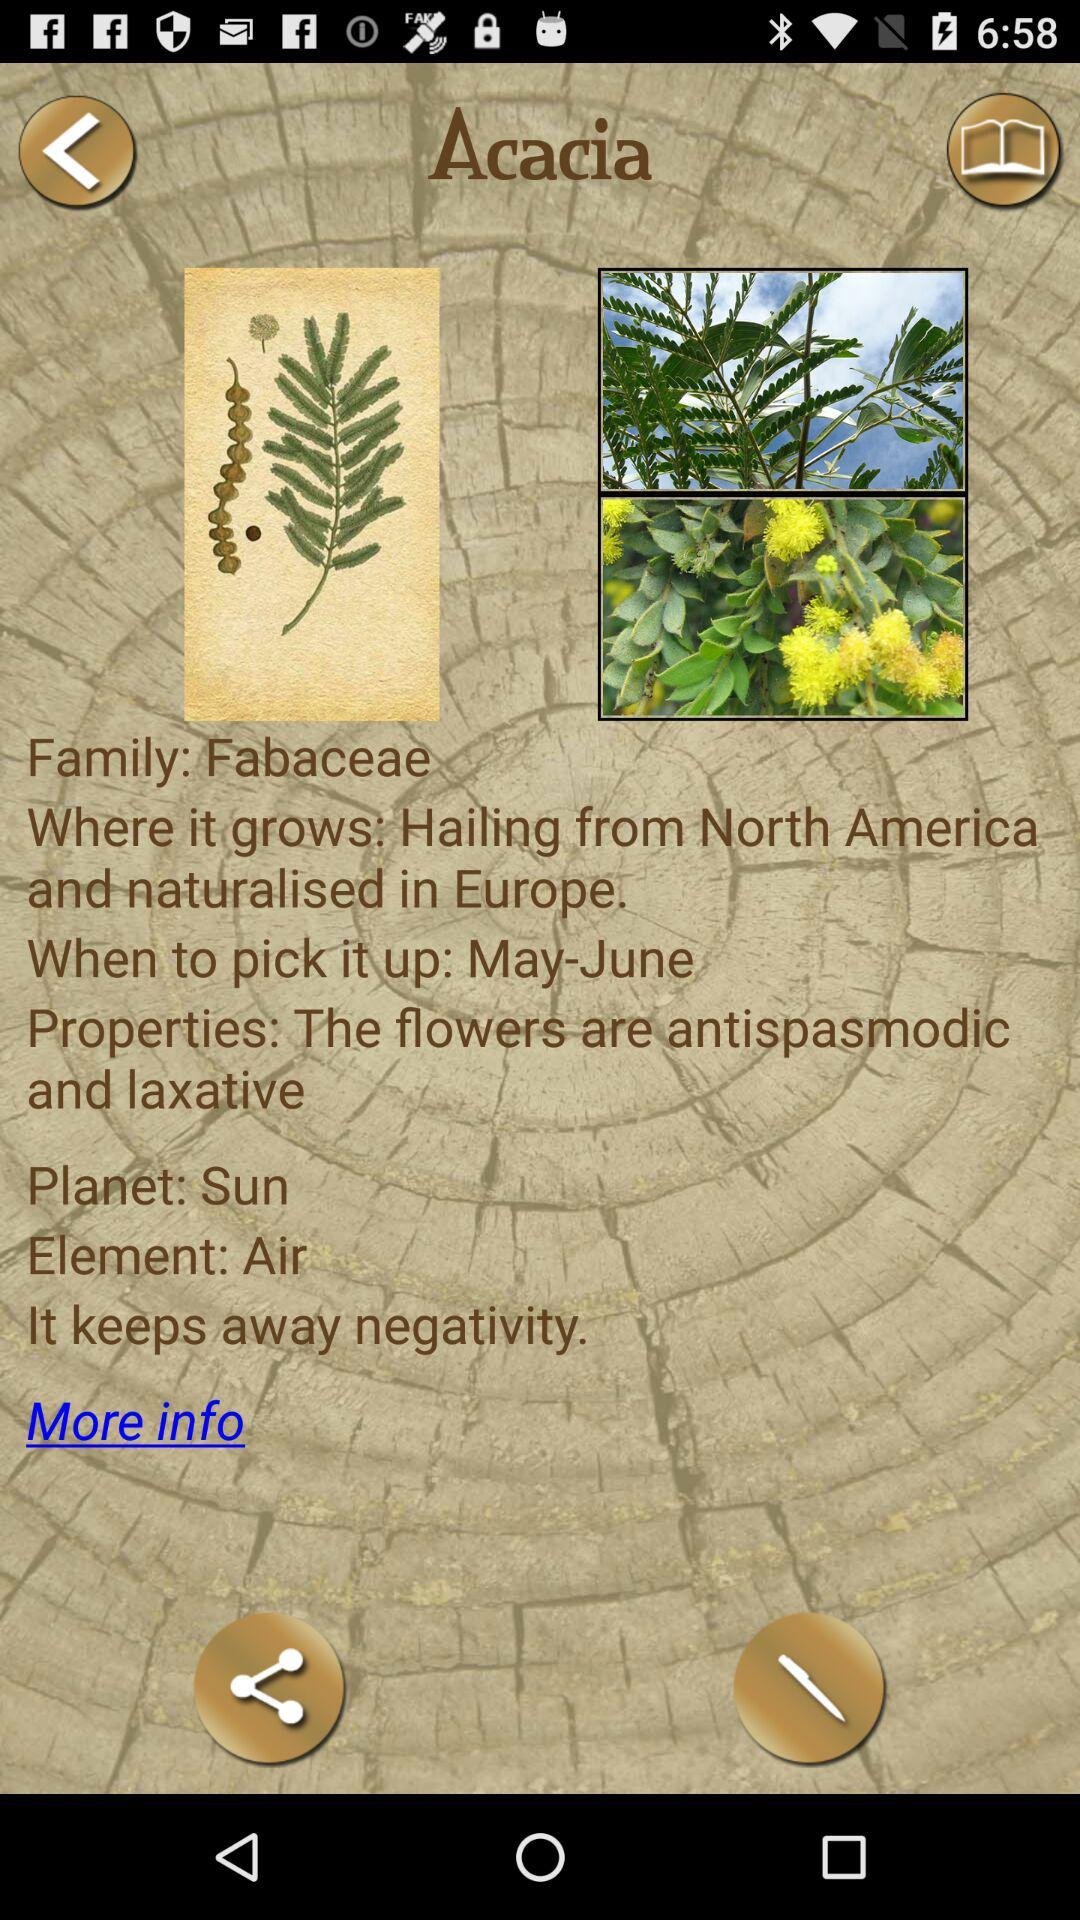Where does Acacia grow? Acacia hails from North America and has naturalised in Europe. 